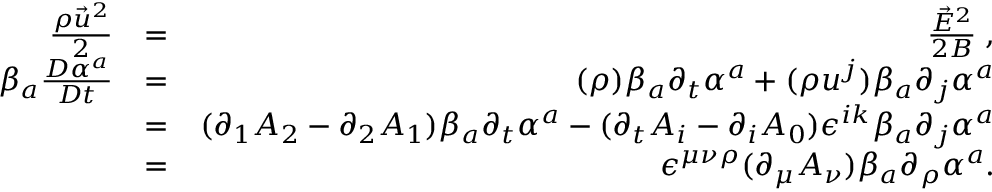<formula> <loc_0><loc_0><loc_500><loc_500>\begin{array} { r l r } { \frac { \rho \vec { u } ^ { 2 } } { 2 } } & { = } & { \frac { \vec { E } ^ { 2 } } { 2 B } \, , } \\ { \beta _ { a } \frac { D \alpha ^ { a } } { D t } } & { = } & { ( \rho ) \beta _ { a } \partial _ { t } \alpha ^ { a } + ( \rho u ^ { j } ) \beta _ { a } \partial _ { j } \alpha ^ { a } } \\ & { = } & { ( \partial _ { 1 } A _ { 2 } - \partial _ { 2 } A _ { 1 } ) \beta _ { a } \partial _ { t } \alpha ^ { a } - ( \partial _ { t } A _ { i } - \partial _ { i } A _ { 0 } ) \epsilon ^ { i k } \beta _ { a } \partial _ { j } \alpha ^ { a } } \\ & { = } & { \epsilon ^ { \mu \nu \rho } ( \partial _ { \mu } A _ { \nu } ) \beta _ { a } \partial _ { \rho } \alpha ^ { a } . } \end{array}</formula> 